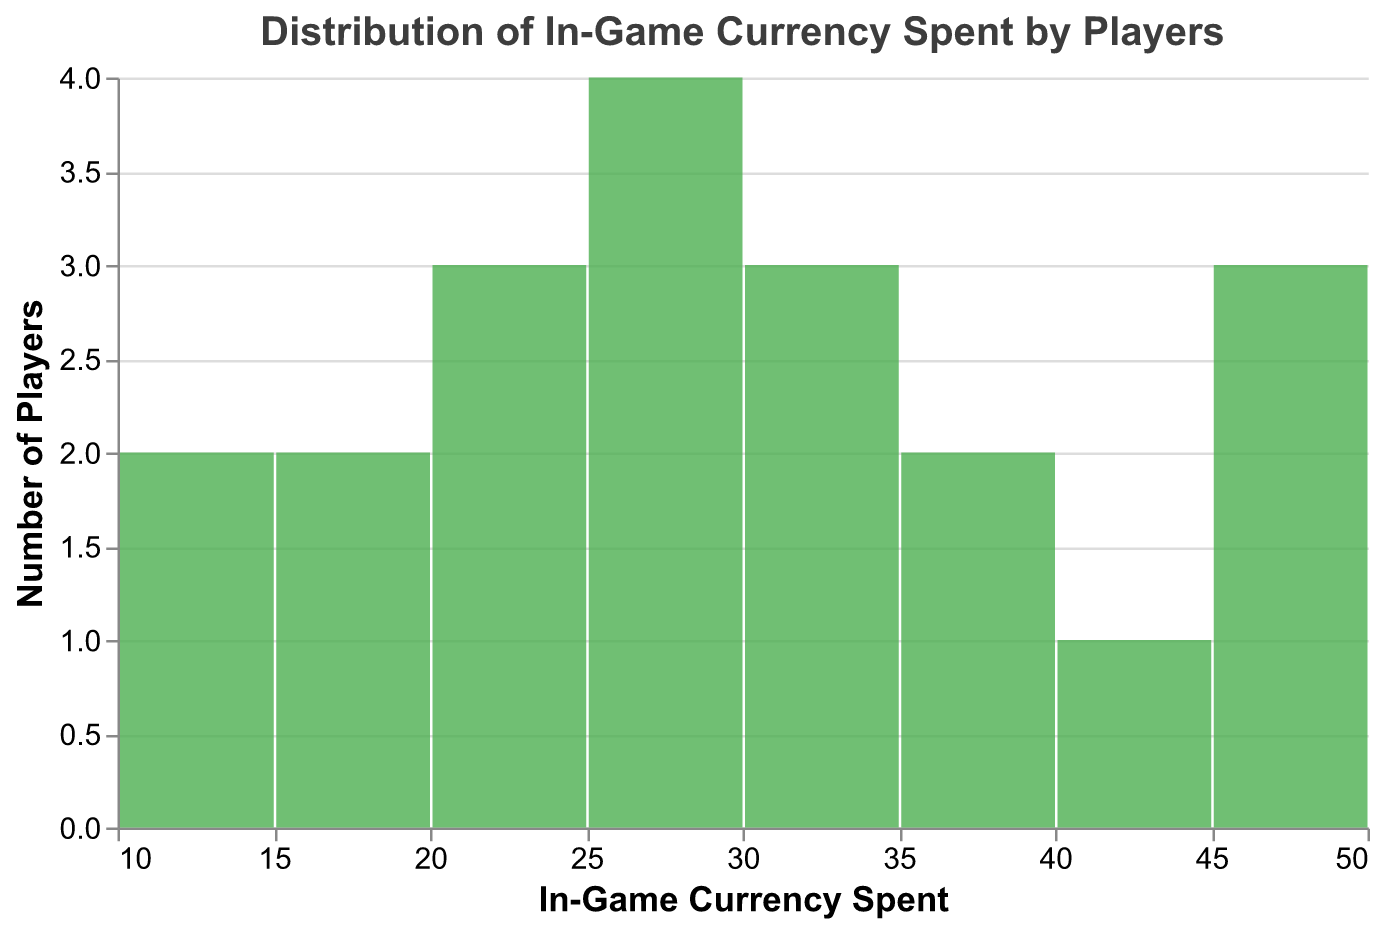What is the title of the figure? The title is positioned at the top of the figure. It is written in Arial font and has a font size of 16.
Answer: "Distribution of In-Game Currency Spent by Players" What color are the bars in the figure? The bars are colored in a shade of green.
Answer: Green What is the highest amount of in-game currency spent by any player? To find the highest spending, we observe the x-axis bin with the maximum range.
Answer: 50 How many players spent between 20 and 30 in-game currency? Identify the bin representing the range of 20 to 30 and count the height of the bar representing the count.
Answer: 6 Which amount range has the highest number of players? Find the bin along the x-axis that has the tallest bar representing the number of players.
Answer: 25 to 30 How many players spent exactly 10 units of in-game currency? Locate the bin that includes the number 10 and observe the count at this bin.
Answer: 2 What is the average amount of in-game currency spent by players? Sum up all the spending amounts and divide by the number of players: (50+35+45+20+30+25+40+50+15+30+25+30+20+10+35+15+25+20+10+25) / 20
Answer: 26 Is there a higher frequency of players who spent less than 25 or more than 25 units of in-game currency? Compare the sum of frequencies of bins less than 25 to those greater than 25. Less than 25: 2 + 2 + 3 + 2 = 9. More than 25: 3 + 2 + 3 + 4 + 2 = 14
Answer: More than 25 How many players spent between 40 and 50 units of in-game currency? Count the number of players in the bins that fall within this range.
Answer: 3 Which player spent the lowest amount of in-game currency? Identify the lowest value on the x-axis and match it to the player in the given data.
Answer: Raheem_Sterling and Jadon_Sancho 